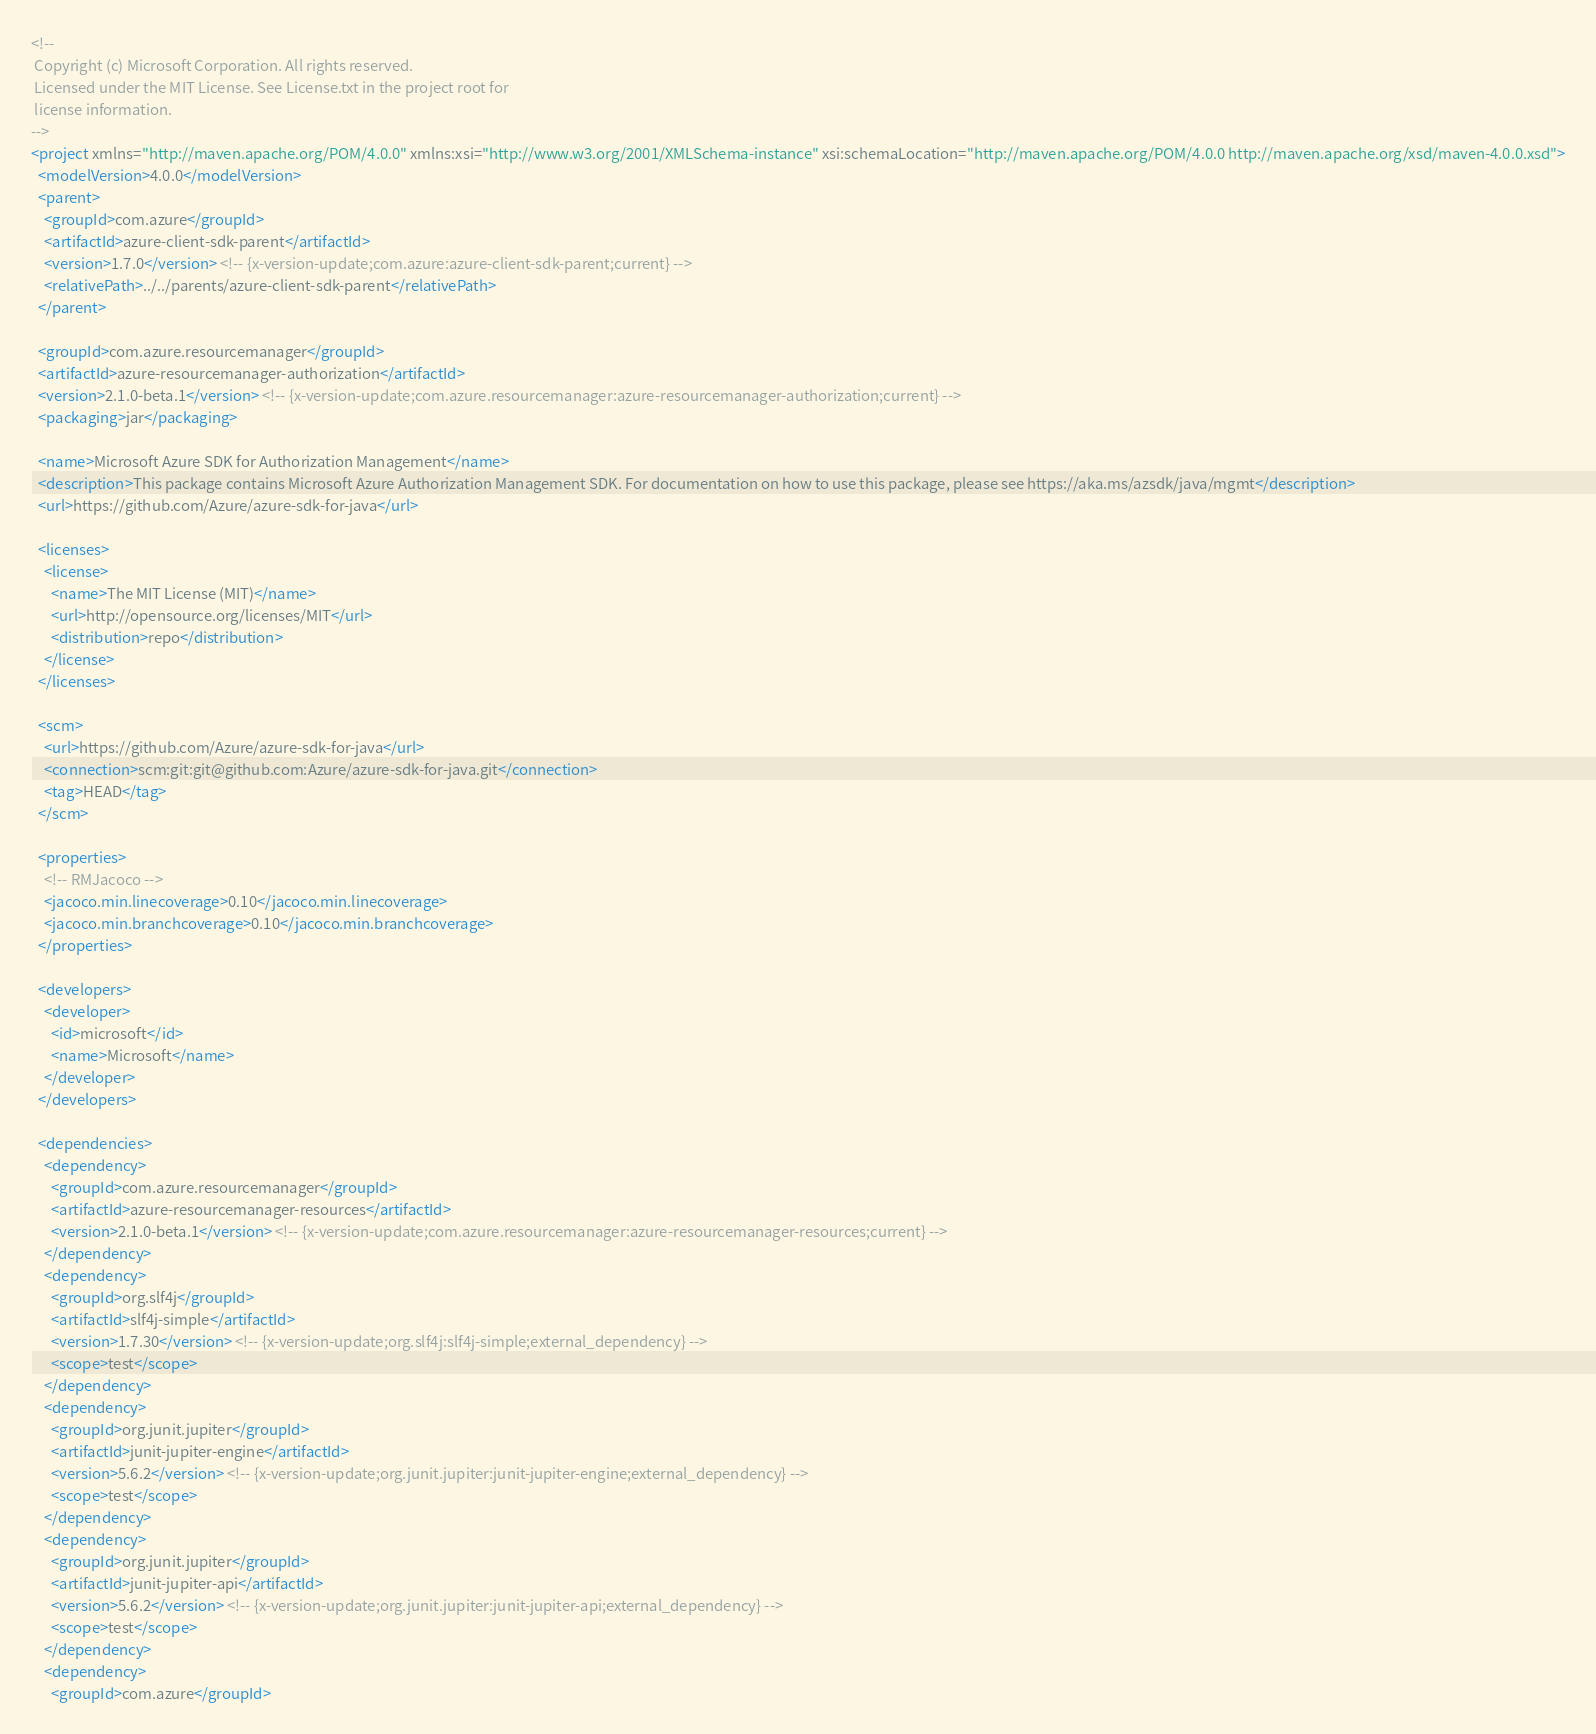<code> <loc_0><loc_0><loc_500><loc_500><_XML_><!--
 Copyright (c) Microsoft Corporation. All rights reserved.
 Licensed under the MIT License. See License.txt in the project root for
 license information.
-->
<project xmlns="http://maven.apache.org/POM/4.0.0" xmlns:xsi="http://www.w3.org/2001/XMLSchema-instance" xsi:schemaLocation="http://maven.apache.org/POM/4.0.0 http://maven.apache.org/xsd/maven-4.0.0.xsd">
  <modelVersion>4.0.0</modelVersion>
  <parent>
    <groupId>com.azure</groupId>
    <artifactId>azure-client-sdk-parent</artifactId>
    <version>1.7.0</version> <!-- {x-version-update;com.azure:azure-client-sdk-parent;current} -->
    <relativePath>../../parents/azure-client-sdk-parent</relativePath>
  </parent>

  <groupId>com.azure.resourcemanager</groupId>
  <artifactId>azure-resourcemanager-authorization</artifactId>
  <version>2.1.0-beta.1</version> <!-- {x-version-update;com.azure.resourcemanager:azure-resourcemanager-authorization;current} -->
  <packaging>jar</packaging>

  <name>Microsoft Azure SDK for Authorization Management</name>
  <description>This package contains Microsoft Azure Authorization Management SDK. For documentation on how to use this package, please see https://aka.ms/azsdk/java/mgmt</description>
  <url>https://github.com/Azure/azure-sdk-for-java</url>

  <licenses>
    <license>
      <name>The MIT License (MIT)</name>
      <url>http://opensource.org/licenses/MIT</url>
      <distribution>repo</distribution>
    </license>
  </licenses>

  <scm>
    <url>https://github.com/Azure/azure-sdk-for-java</url>
    <connection>scm:git:git@github.com:Azure/azure-sdk-for-java.git</connection>
    <tag>HEAD</tag>
  </scm>

  <properties>
    <!-- RMJacoco -->
    <jacoco.min.linecoverage>0.10</jacoco.min.linecoverage>
    <jacoco.min.branchcoverage>0.10</jacoco.min.branchcoverage>
  </properties>

  <developers>
    <developer>
      <id>microsoft</id>
      <name>Microsoft</name>
    </developer>
  </developers>

  <dependencies>
    <dependency>
      <groupId>com.azure.resourcemanager</groupId>
      <artifactId>azure-resourcemanager-resources</artifactId>
      <version>2.1.0-beta.1</version> <!-- {x-version-update;com.azure.resourcemanager:azure-resourcemanager-resources;current} -->
    </dependency>
    <dependency>
      <groupId>org.slf4j</groupId>
      <artifactId>slf4j-simple</artifactId>
      <version>1.7.30</version> <!-- {x-version-update;org.slf4j:slf4j-simple;external_dependency} -->
      <scope>test</scope>
    </dependency>
    <dependency>
      <groupId>org.junit.jupiter</groupId>
      <artifactId>junit-jupiter-engine</artifactId>
      <version>5.6.2</version> <!-- {x-version-update;org.junit.jupiter:junit-jupiter-engine;external_dependency} -->
      <scope>test</scope>
    </dependency>
    <dependency>
      <groupId>org.junit.jupiter</groupId>
      <artifactId>junit-jupiter-api</artifactId>
      <version>5.6.2</version> <!-- {x-version-update;org.junit.jupiter:junit-jupiter-api;external_dependency} -->
      <scope>test</scope>
    </dependency>
    <dependency>
      <groupId>com.azure</groupId></code> 